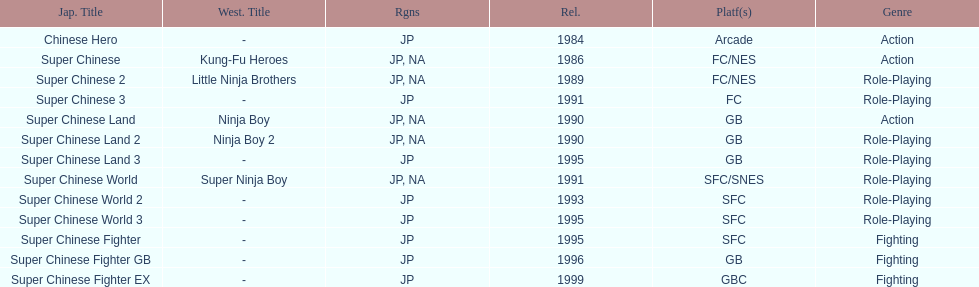When was the last super chinese game released? 1999. 